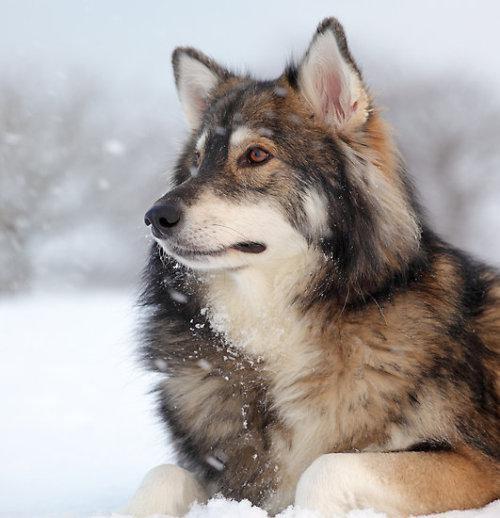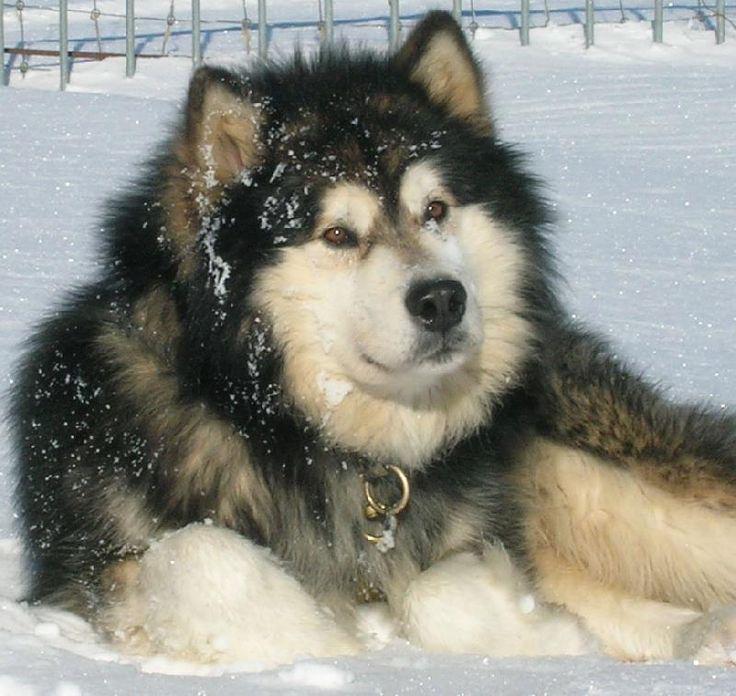The first image is the image on the left, the second image is the image on the right. Considering the images on both sides, is "The right image features a dog with dark fur framing a white-furred face and snow on some of its fur." valid? Answer yes or no. Yes. The first image is the image on the left, the second image is the image on the right. Evaluate the accuracy of this statement regarding the images: "There is exactly one dog outside in the snow in every photo, and both dogs either have their mouths closed or they both have them open.". Is it true? Answer yes or no. Yes. 